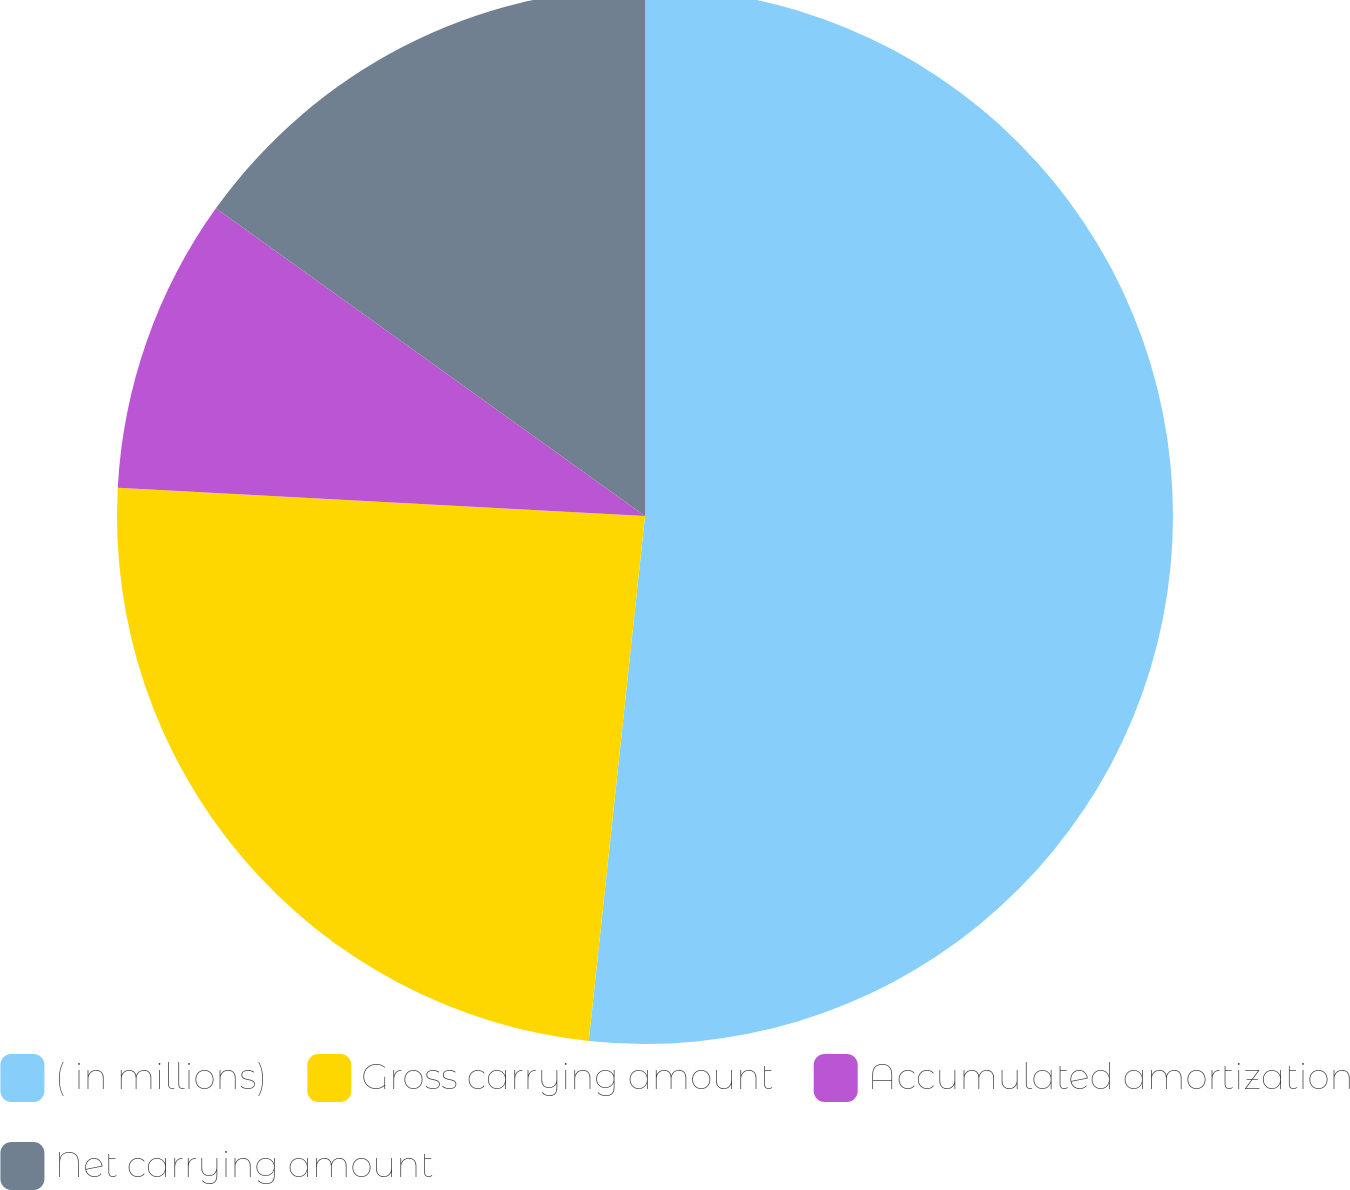Convert chart. <chart><loc_0><loc_0><loc_500><loc_500><pie_chart><fcel>( in millions)<fcel>Gross carrying amount<fcel>Accumulated amortization<fcel>Net carrying amount<nl><fcel>51.7%<fcel>24.15%<fcel>9.05%<fcel>15.1%<nl></chart> 